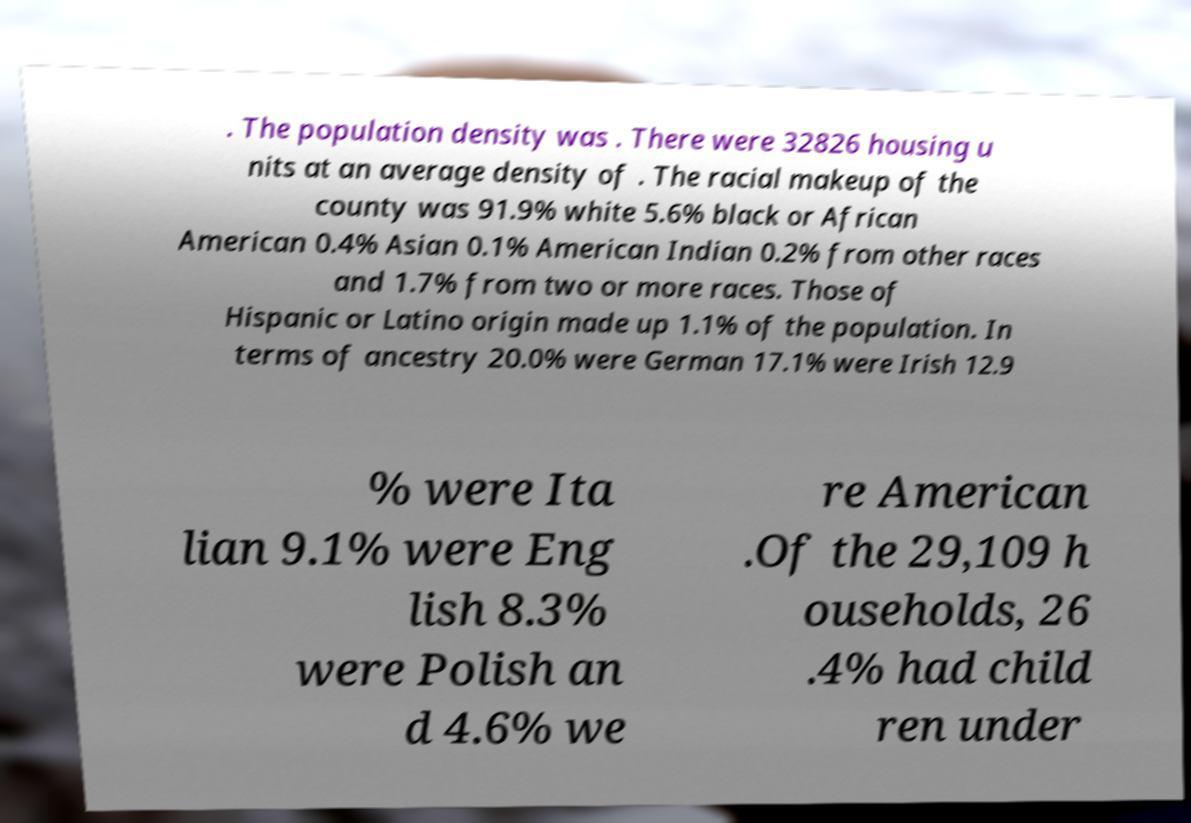Could you extract and type out the text from this image? . The population density was . There were 32826 housing u nits at an average density of . The racial makeup of the county was 91.9% white 5.6% black or African American 0.4% Asian 0.1% American Indian 0.2% from other races and 1.7% from two or more races. Those of Hispanic or Latino origin made up 1.1% of the population. In terms of ancestry 20.0% were German 17.1% were Irish 12.9 % were Ita lian 9.1% were Eng lish 8.3% were Polish an d 4.6% we re American .Of the 29,109 h ouseholds, 26 .4% had child ren under 